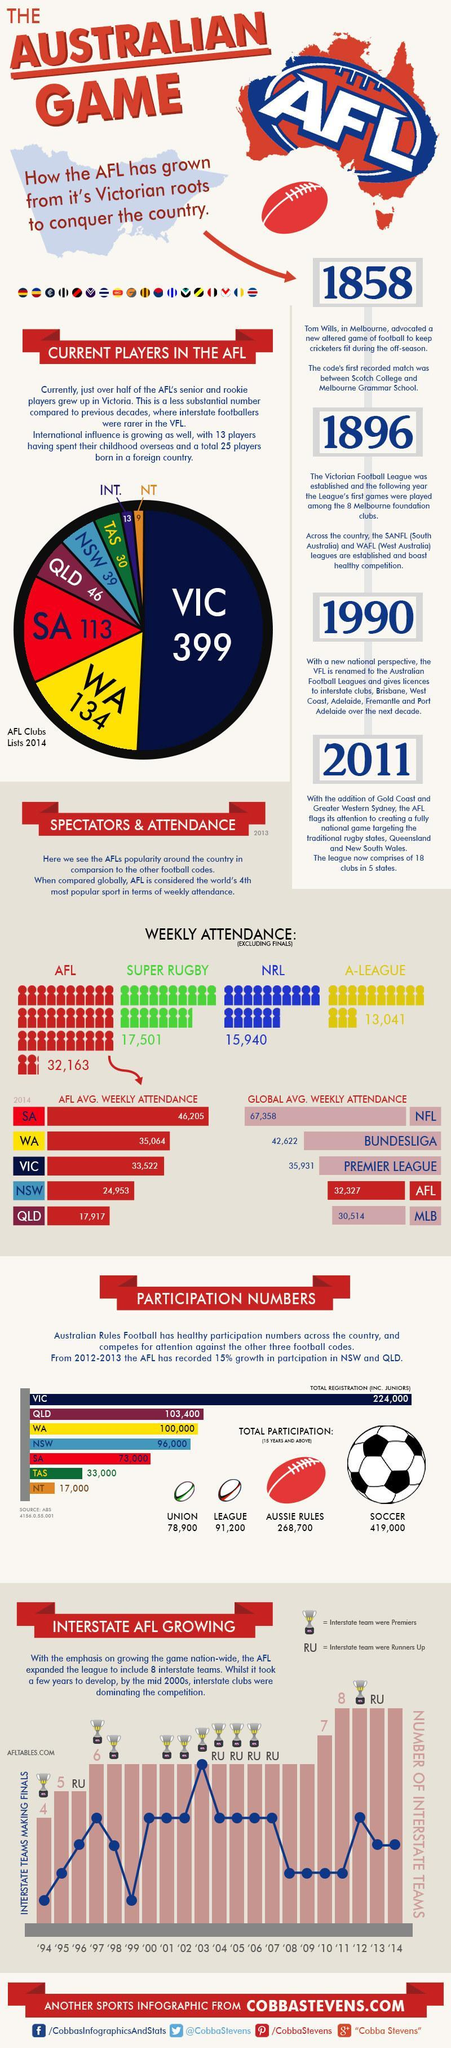What is the difference in the participation numbers between West Australia and New South Wales?
Answer the question with a short phrase. 4,000 In which year did the interstate clubs register the maximum participation, 2002, 2003, or 2004? 2003 What is difference in the global average weekly attendance between NFL and AFL? 35,031 Which region does the second highest numbers of AFL players hail from? West Australia Which year has the lowest participation recorded by the interstate clubs, 2000, 1998, or 1999? 1999 To which region did  113 players from the current  AFL team belong to, South Australia, West Australia, or Victoria? South Australia What is the difference  average weekly attendance in of  SA and NSW in AFL ? 21,252 